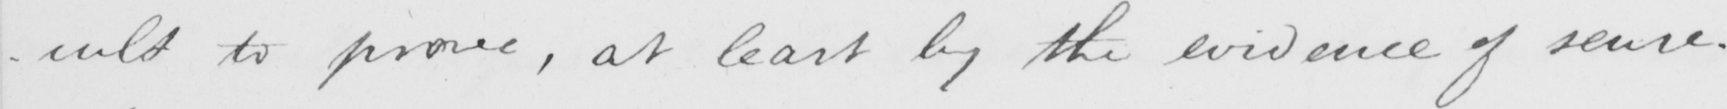What does this handwritten line say? -cult to prove , at least by the evidence of sense . 